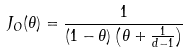Convert formula to latex. <formula><loc_0><loc_0><loc_500><loc_500>J _ { O } ( \theta ) = \frac { 1 } { ( 1 - \theta ) \left ( \theta + \frac { 1 } { d - 1 } \right ) }</formula> 